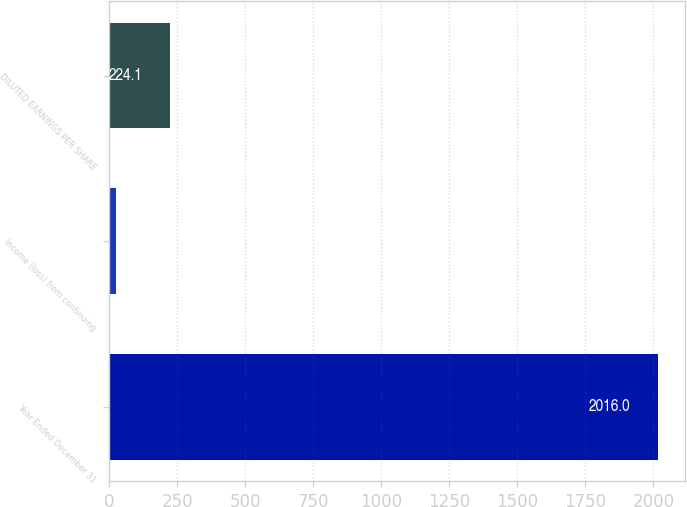Convert chart. <chart><loc_0><loc_0><loc_500><loc_500><bar_chart><fcel>Year Ended December 31<fcel>Income (loss) from continuing<fcel>DILUTED EARNINGS PER SHARE<nl><fcel>2016<fcel>25<fcel>224.1<nl></chart> 